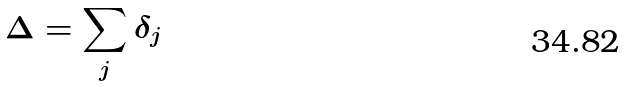Convert formula to latex. <formula><loc_0><loc_0><loc_500><loc_500>\Delta = \sum _ { j } \delta _ { j }</formula> 